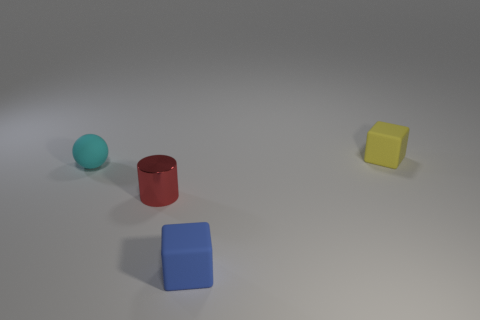Is the color of the small cylinder the same as the small ball?
Offer a terse response. No. Is the number of small green cylinders less than the number of tiny blue rubber blocks?
Your answer should be compact. Yes. There is a small cube that is left of the yellow rubber cube; what is it made of?
Your answer should be very brief. Rubber. What is the material of the cyan object that is the same size as the cylinder?
Your answer should be compact. Rubber. The tiny cube that is to the left of the tiny rubber cube that is right of the small block in front of the red metallic cylinder is made of what material?
Offer a terse response. Rubber. Do the rubber thing that is in front of the cylinder and the small red metallic cylinder have the same size?
Give a very brief answer. Yes. Are there more cyan objects than things?
Your answer should be compact. No. What number of large objects are either rubber cubes or brown things?
Offer a terse response. 0. What number of other objects are there of the same color as the metal object?
Offer a terse response. 0. How many things have the same material as the tiny yellow block?
Give a very brief answer. 2. 